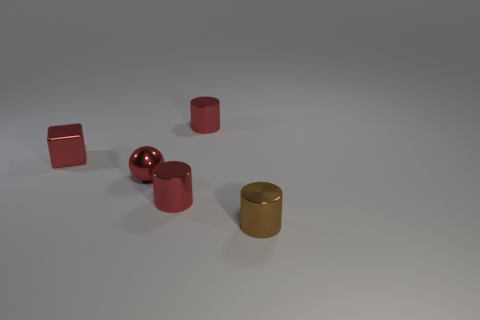Add 3 tiny green cubes. How many objects exist? 8 Subtract all brown metallic cylinders. How many cylinders are left? 2 Subtract all blue cubes. How many green balls are left? 0 Subtract all red things. Subtract all tiny red metal spheres. How many objects are left? 0 Add 3 small red cylinders. How many small red cylinders are left? 5 Add 5 tiny red cylinders. How many tiny red cylinders exist? 7 Subtract all brown cylinders. How many cylinders are left? 2 Subtract 0 yellow blocks. How many objects are left? 5 Subtract all blocks. How many objects are left? 4 Subtract 1 balls. How many balls are left? 0 